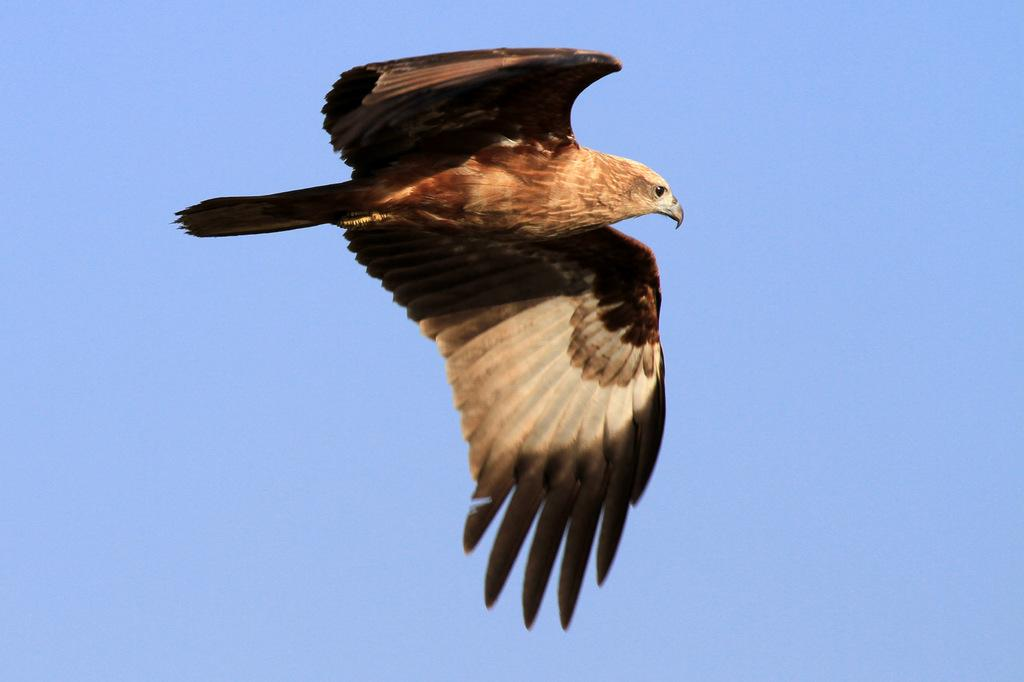What animal is in the foreground of the image? There is an eagle in the foreground of the image. What is the eagle doing in the image? The eagle is in the air. What can be seen in the background of the image? The sky is visible in the background of the image. What type of orange is the fireman holding in the image? There is no fireman or orange present in the image; it features an eagle in the air. Is there a volcano visible in the image? No, there is no volcano present in the image; it features an eagle in the air with the sky visible in the background. 